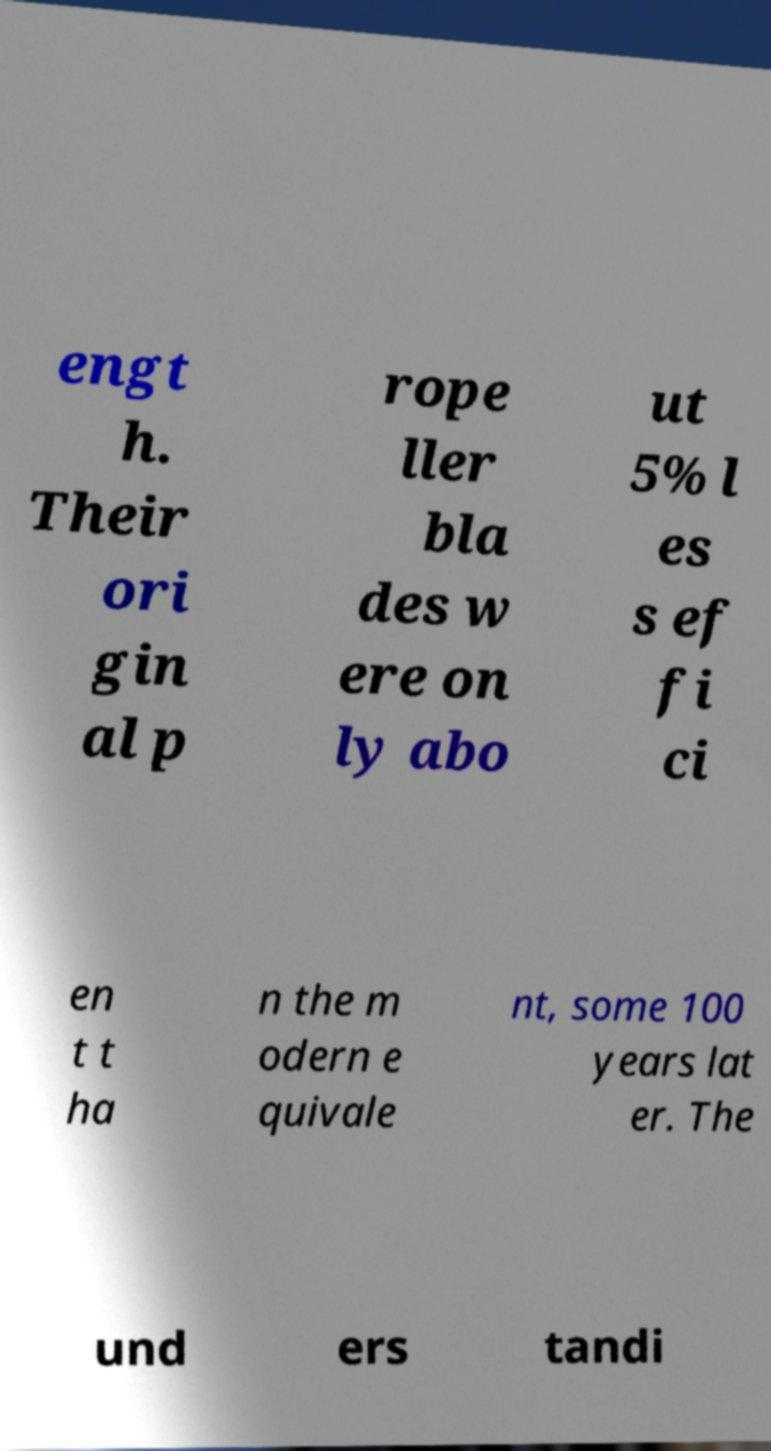Could you extract and type out the text from this image? engt h. Their ori gin al p rope ller bla des w ere on ly abo ut 5% l es s ef fi ci en t t ha n the m odern e quivale nt, some 100 years lat er. The und ers tandi 